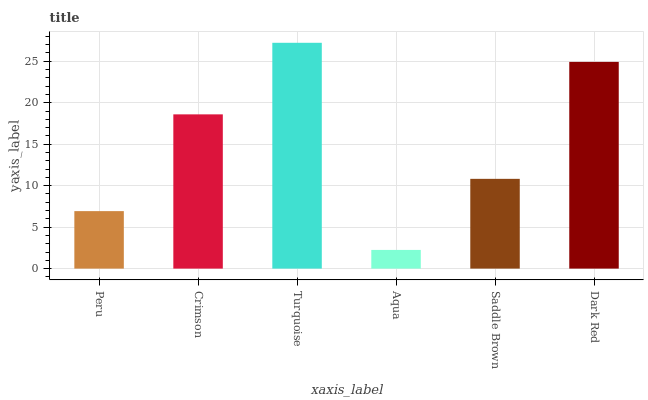Is Aqua the minimum?
Answer yes or no. Yes. Is Turquoise the maximum?
Answer yes or no. Yes. Is Crimson the minimum?
Answer yes or no. No. Is Crimson the maximum?
Answer yes or no. No. Is Crimson greater than Peru?
Answer yes or no. Yes. Is Peru less than Crimson?
Answer yes or no. Yes. Is Peru greater than Crimson?
Answer yes or no. No. Is Crimson less than Peru?
Answer yes or no. No. Is Crimson the high median?
Answer yes or no. Yes. Is Saddle Brown the low median?
Answer yes or no. Yes. Is Turquoise the high median?
Answer yes or no. No. Is Dark Red the low median?
Answer yes or no. No. 